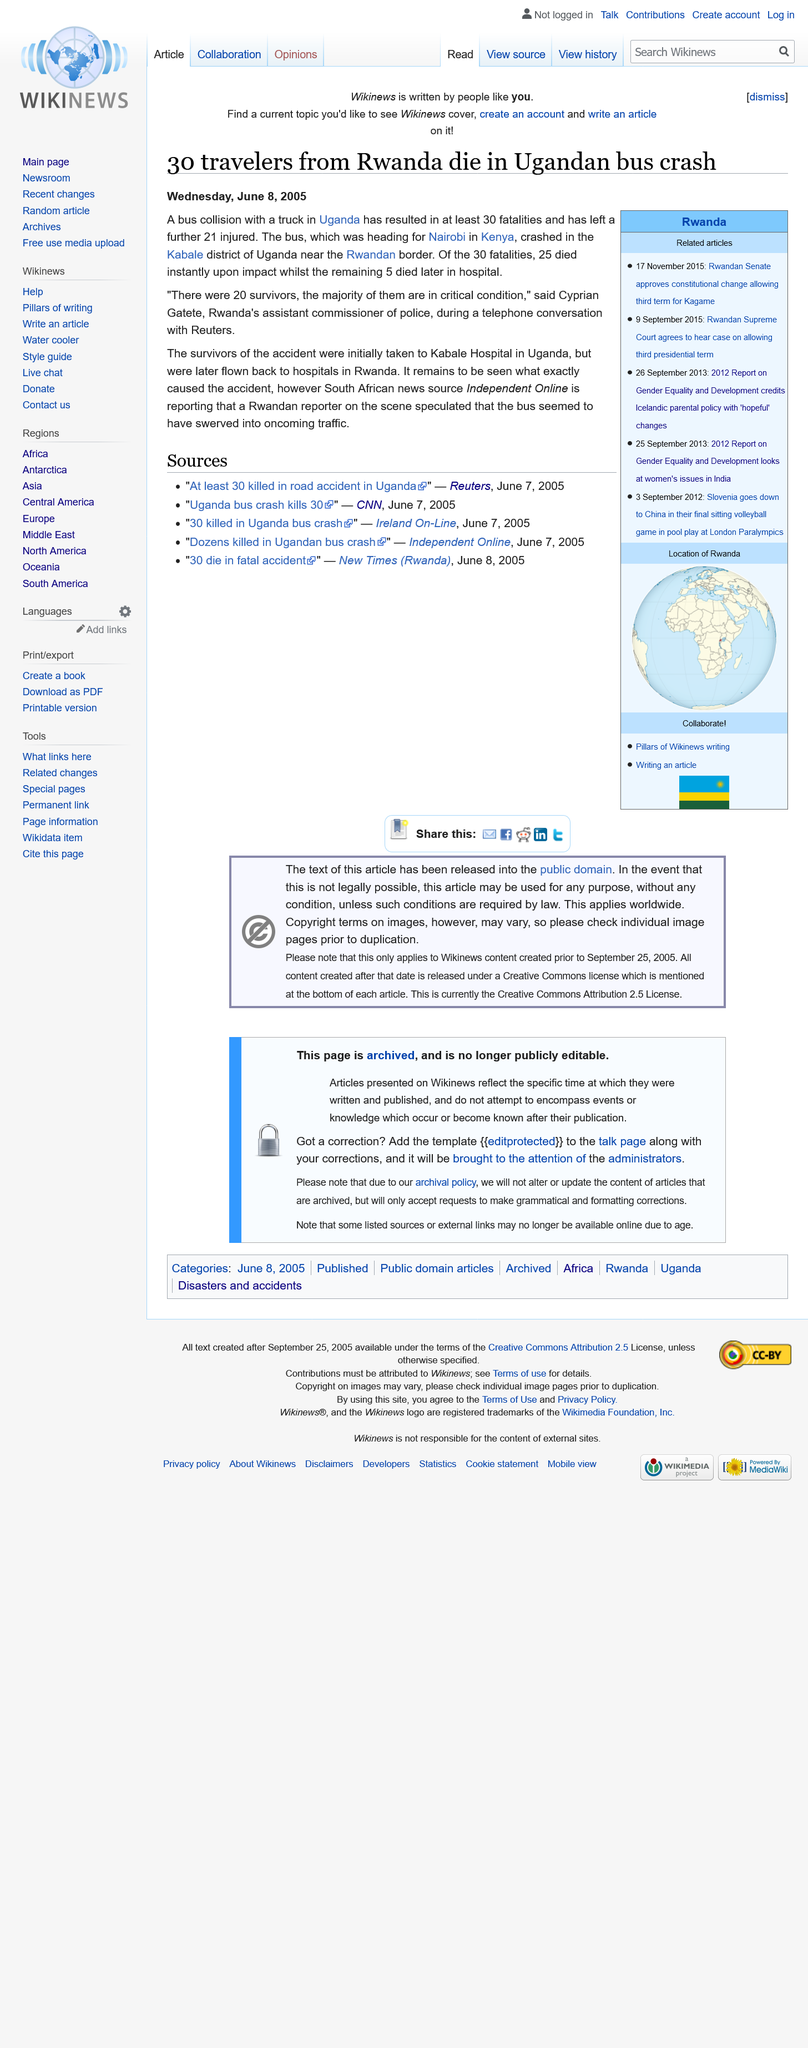Mention a couple of crucial points in this snapshot. The bus accident occurred in the Kabale district of Uganda. At least 30 fatalities occurred. In the aftermath of the accident, 20 survivors were rescued and taken to Kabale Hospital in Uganda for treatment. 